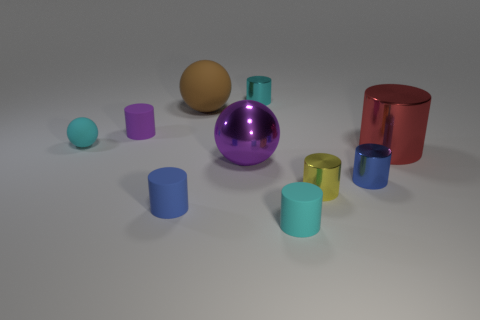How big is the shiny cylinder right of the small blue metallic cylinder? The shiny cylinder to the right of the small blue metallic cylinder is quite significant in size, notably larger than both the blue cylinder and several other objects displayed. Its height appears to be roughly twice that of the blue cylinder next to it, and its diameter is wider as well. 